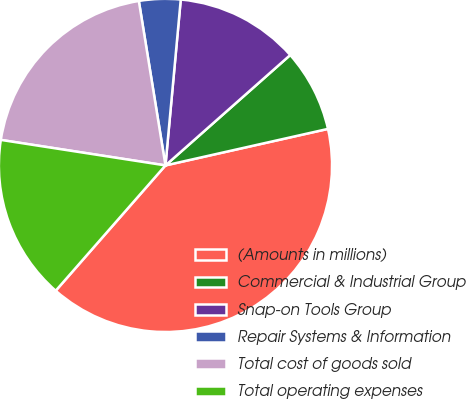Convert chart. <chart><loc_0><loc_0><loc_500><loc_500><pie_chart><fcel>(Amounts in millions)<fcel>Commercial & Industrial Group<fcel>Snap-on Tools Group<fcel>Repair Systems & Information<fcel>Total cost of goods sold<fcel>Total operating expenses<nl><fcel>39.97%<fcel>8.01%<fcel>12.01%<fcel>4.02%<fcel>20.0%<fcel>16.0%<nl></chart> 